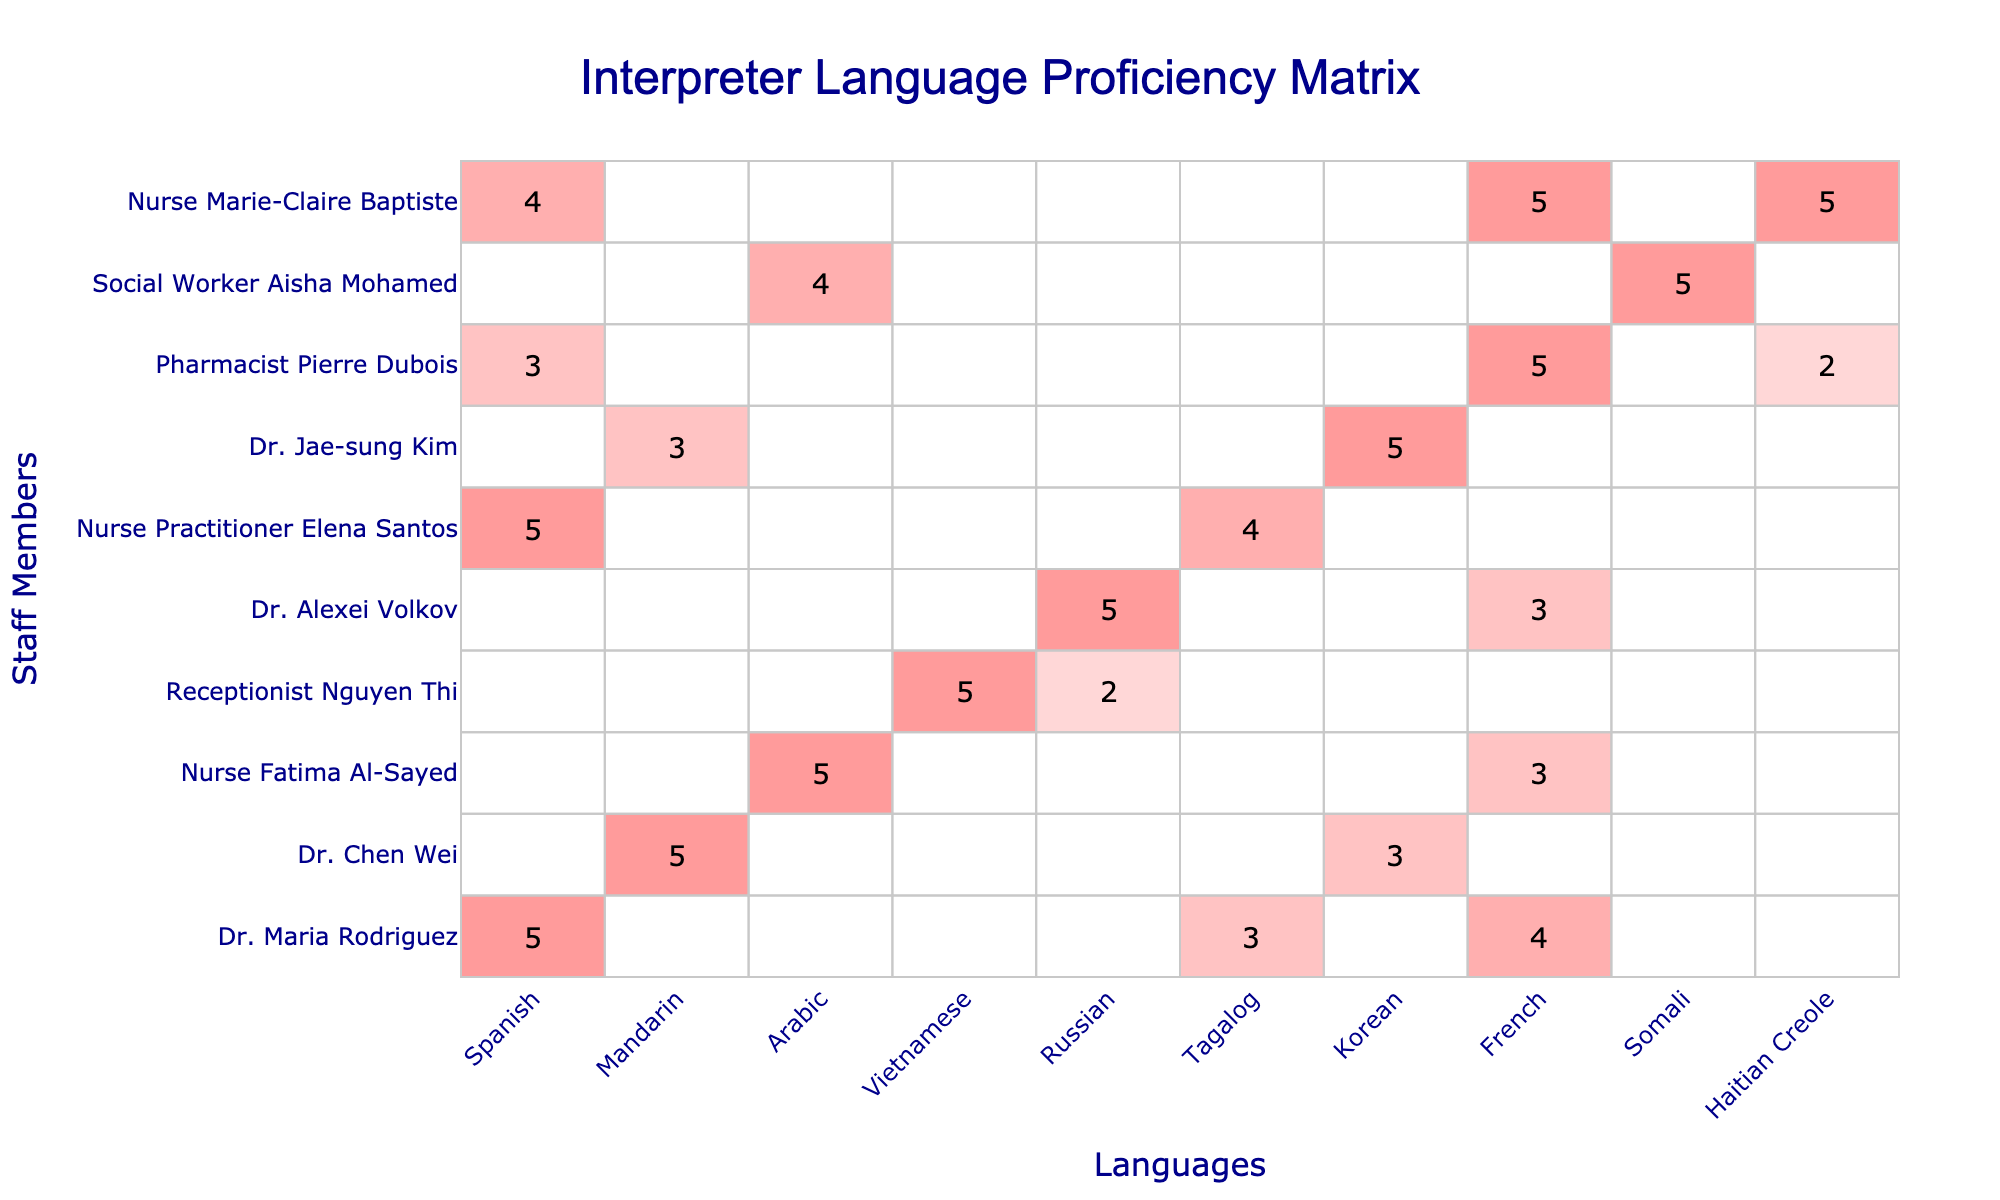What is the highest proficiency level for Spanish among staff members? Dr. Maria Rodriguez has a proficiency level of 5 in Spanish, which is the highest value listed in the table.
Answer: 5 Which staff member has the highest proficiency in Arabic? Nurse Fatima Al-Sayed has a proficiency level of 5 in Arabic, which is the highest value listed for that language in the table.
Answer: Nurse Fatima Al-Sayed How many staff members are proficient in Mandarin? Only Dr. Chen Wei and Dr. Jae-sung Kim are listed with proficiency in Mandarin, with proficiency levels of 5 and 3 respectively.
Answer: 2 What is the average proficiency level in Vietnamese across all staff members? The only staff member with proficiency in Vietnamese is Receptionist Nguyen Thi, who has a level of 5. Therefore, the average is 5.
Answer: 5 Do any staff members have proficiency in Tagalog and French? Yes, both Dr. Maria Rodriguez and Dr. Jae-sung Kim have proficiency levels in Tagalog, while Dr. Chen Wei and Pharmacist Pierre Dubois have proficiency levels in French.
Answer: Yes Which language has the highest total proficiency across all staff members? By summing the proficiency levels: Spanish (5 + 5 + 5 + 4 = 19), Mandarin (5 + 3 = 8), Arabic (5 + 4 = 9), Vietnamese (5), Russian (5), Tagalog (3 + 4 = 7), French (3 + 5 = 8), Somali (5), and Haitian Creole (2). The highest is for Spanish with a total of 19.
Answer: Spanish Is there any staff member who is bilingual? Yes, Dr. Maria Rodriguez speaks both Spanish (5) and Tagalog (3), and Nurse Marie-Claire Baptiste speaks both Spanish (4) and French (5).
Answer: Yes What is the total proficiency level for Dr. Alexei Volkov across all languages? Dr. Alexei Volkov has a proficiency of 5 in Russian and a proficiency of 3 in Somali, giving him a total of 8.
Answer: 8 Which language has the lowest total proficiency level across all staff members? Summing up the proficiency for each language, Haitian Creole has the lowest total with only a proficiency of 2.
Answer: Haitian Creole How many languages does Nurse Fatima Al-Sayed speak? Nurse Fatima Al-Sayed has proficiency in Arabic (5) and Somali (3); thus, she speaks a total of 2 languages.
Answer: 2 